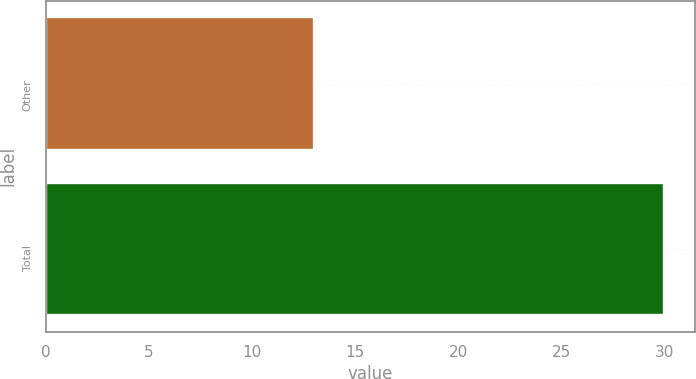<chart> <loc_0><loc_0><loc_500><loc_500><bar_chart><fcel>Other<fcel>Total<nl><fcel>13<fcel>30<nl></chart> 